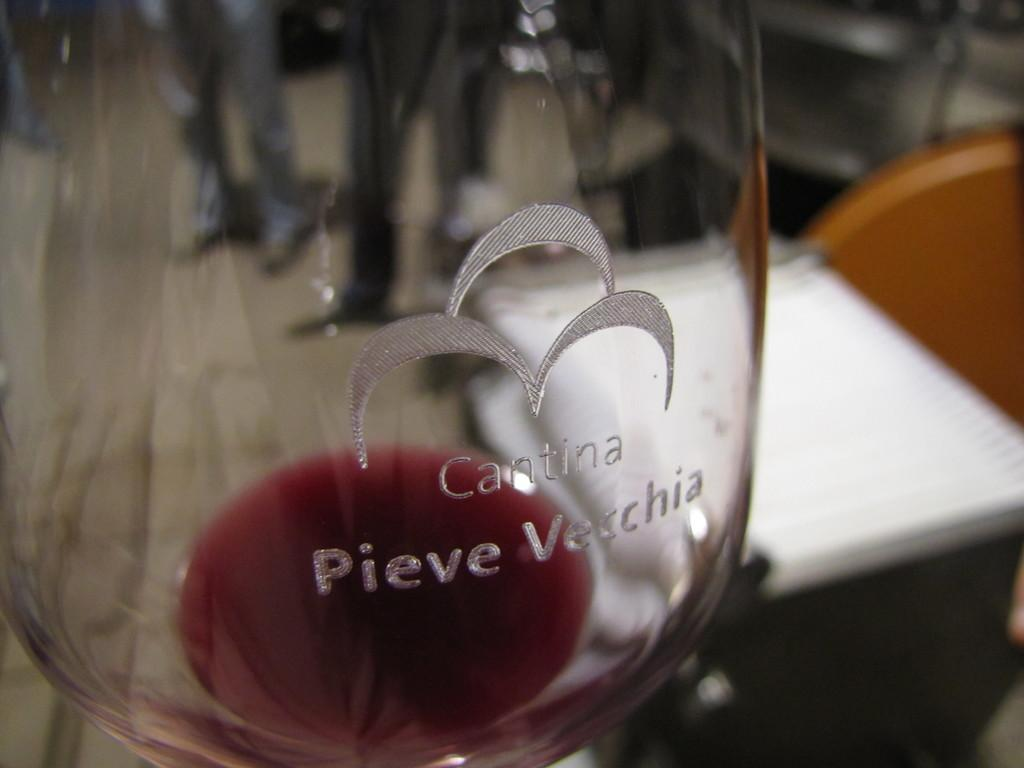<image>
Present a compact description of the photo's key features. An almost empty wine glass with Cantina Pieve Vecchia etched on it. 